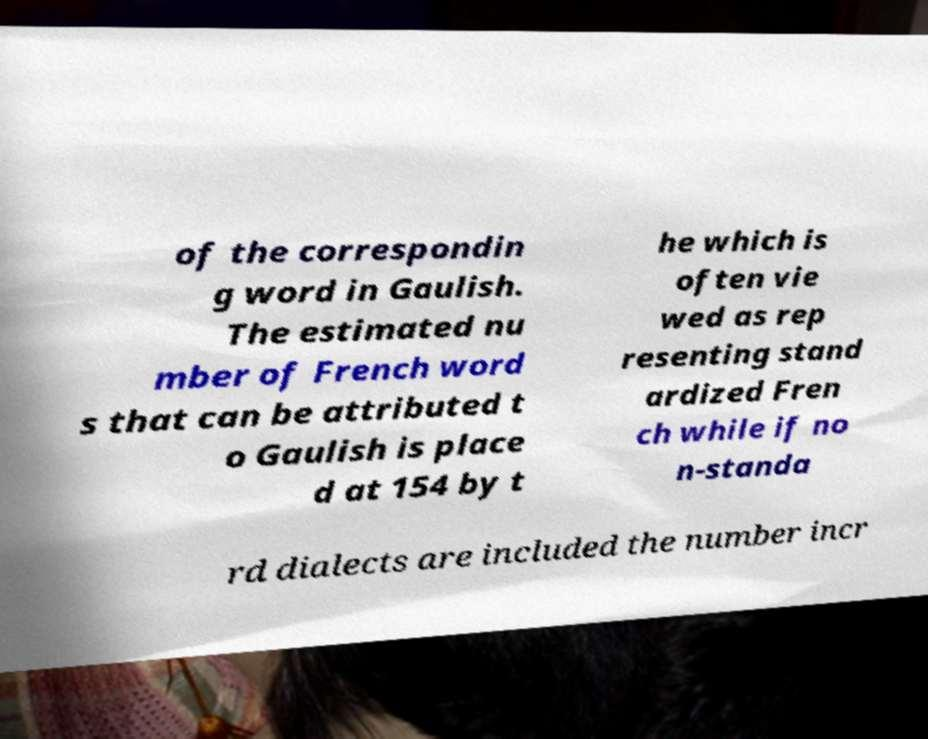Could you extract and type out the text from this image? of the correspondin g word in Gaulish. The estimated nu mber of French word s that can be attributed t o Gaulish is place d at 154 by t he which is often vie wed as rep resenting stand ardized Fren ch while if no n-standa rd dialects are included the number incr 